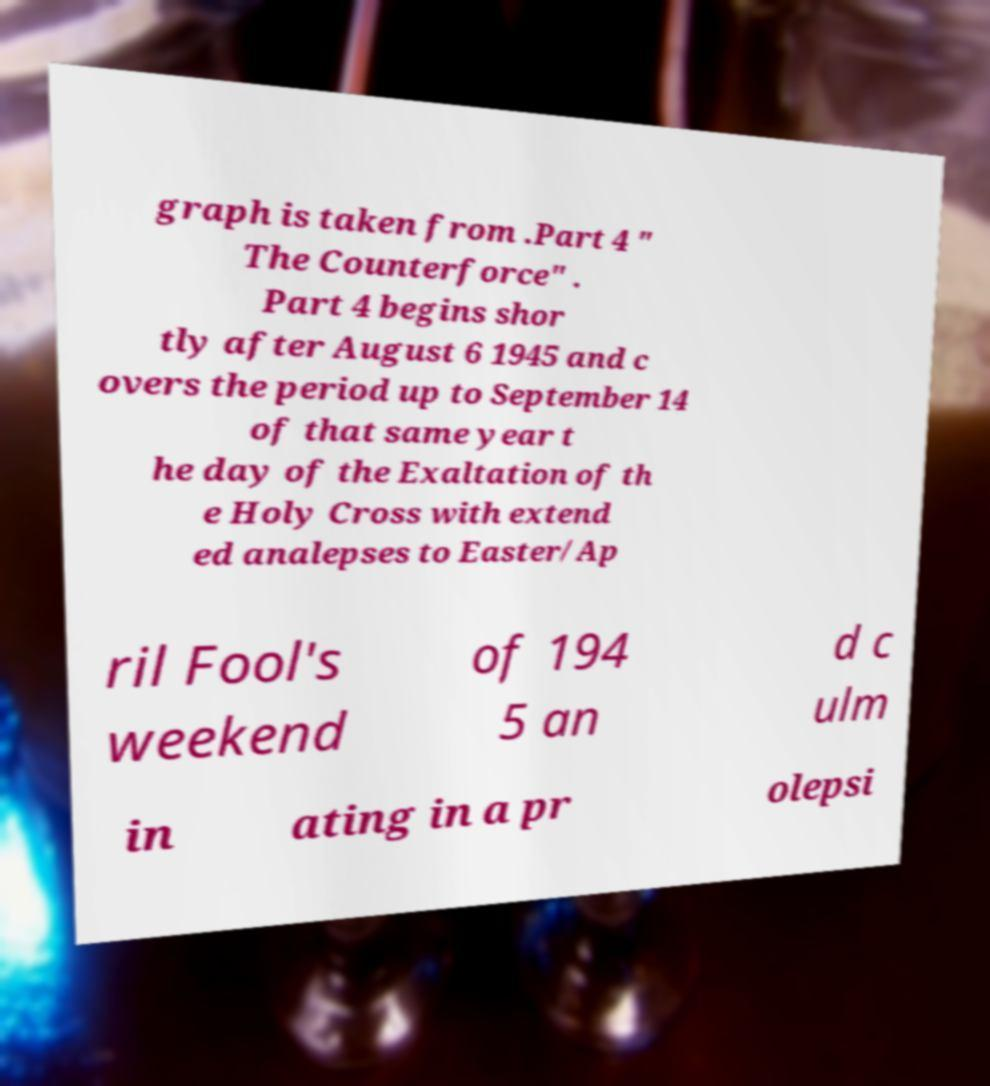Could you assist in decoding the text presented in this image and type it out clearly? graph is taken from .Part 4 " The Counterforce" . Part 4 begins shor tly after August 6 1945 and c overs the period up to September 14 of that same year t he day of the Exaltation of th e Holy Cross with extend ed analepses to Easter/Ap ril Fool's weekend of 194 5 an d c ulm in ating in a pr olepsi 